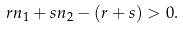<formula> <loc_0><loc_0><loc_500><loc_500>r n _ { 1 } + s n _ { 2 } - ( r + s ) > 0 .</formula> 